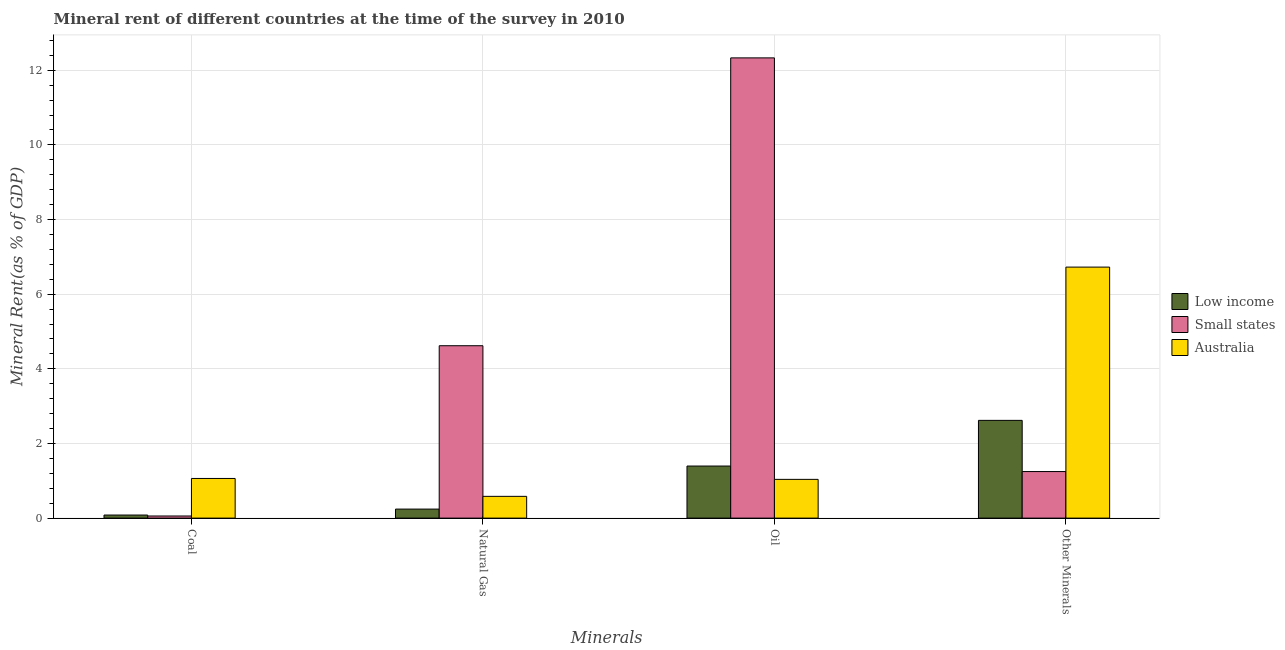Are the number of bars on each tick of the X-axis equal?
Keep it short and to the point. Yes. How many bars are there on the 1st tick from the right?
Provide a succinct answer. 3. What is the label of the 2nd group of bars from the left?
Ensure brevity in your answer.  Natural Gas. What is the natural gas rent in Small states?
Keep it short and to the point. 4.62. Across all countries, what is the maximum natural gas rent?
Your response must be concise. 4.62. Across all countries, what is the minimum  rent of other minerals?
Make the answer very short. 1.25. In which country was the  rent of other minerals minimum?
Make the answer very short. Small states. What is the total natural gas rent in the graph?
Provide a succinct answer. 5.44. What is the difference between the oil rent in Small states and that in Low income?
Your response must be concise. 10.94. What is the difference between the natural gas rent in Australia and the oil rent in Small states?
Your answer should be very brief. -11.75. What is the average coal rent per country?
Provide a short and direct response. 0.4. What is the difference between the coal rent and  rent of other minerals in Low income?
Your answer should be compact. -2.54. What is the ratio of the natural gas rent in Low income to that in Small states?
Provide a short and direct response. 0.05. Is the  rent of other minerals in Low income less than that in Small states?
Ensure brevity in your answer.  No. What is the difference between the highest and the second highest natural gas rent?
Ensure brevity in your answer.  4.04. What is the difference between the highest and the lowest  rent of other minerals?
Give a very brief answer. 5.48. What does the 1st bar from the right in Other Minerals represents?
Make the answer very short. Australia. What is the difference between two consecutive major ticks on the Y-axis?
Provide a short and direct response. 2. Are the values on the major ticks of Y-axis written in scientific E-notation?
Make the answer very short. No. Does the graph contain any zero values?
Offer a very short reply. No. Does the graph contain grids?
Offer a very short reply. Yes. How are the legend labels stacked?
Provide a short and direct response. Vertical. What is the title of the graph?
Give a very brief answer. Mineral rent of different countries at the time of the survey in 2010. Does "Denmark" appear as one of the legend labels in the graph?
Provide a short and direct response. No. What is the label or title of the X-axis?
Give a very brief answer. Minerals. What is the label or title of the Y-axis?
Provide a succinct answer. Mineral Rent(as % of GDP). What is the Mineral Rent(as % of GDP) in Low income in Coal?
Offer a very short reply. 0.08. What is the Mineral Rent(as % of GDP) of Small states in Coal?
Offer a very short reply. 0.06. What is the Mineral Rent(as % of GDP) of Australia in Coal?
Keep it short and to the point. 1.06. What is the Mineral Rent(as % of GDP) of Low income in Natural Gas?
Ensure brevity in your answer.  0.24. What is the Mineral Rent(as % of GDP) in Small states in Natural Gas?
Offer a terse response. 4.62. What is the Mineral Rent(as % of GDP) in Australia in Natural Gas?
Offer a very short reply. 0.58. What is the Mineral Rent(as % of GDP) in Low income in Oil?
Your answer should be very brief. 1.4. What is the Mineral Rent(as % of GDP) of Small states in Oil?
Your answer should be very brief. 12.33. What is the Mineral Rent(as % of GDP) in Australia in Oil?
Offer a very short reply. 1.04. What is the Mineral Rent(as % of GDP) of Low income in Other Minerals?
Give a very brief answer. 2.62. What is the Mineral Rent(as % of GDP) of Small states in Other Minerals?
Offer a terse response. 1.25. What is the Mineral Rent(as % of GDP) in Australia in Other Minerals?
Provide a succinct answer. 6.72. Across all Minerals, what is the maximum Mineral Rent(as % of GDP) in Low income?
Your response must be concise. 2.62. Across all Minerals, what is the maximum Mineral Rent(as % of GDP) of Small states?
Provide a succinct answer. 12.33. Across all Minerals, what is the maximum Mineral Rent(as % of GDP) of Australia?
Provide a succinct answer. 6.72. Across all Minerals, what is the minimum Mineral Rent(as % of GDP) in Low income?
Give a very brief answer. 0.08. Across all Minerals, what is the minimum Mineral Rent(as % of GDP) in Small states?
Keep it short and to the point. 0.06. Across all Minerals, what is the minimum Mineral Rent(as % of GDP) of Australia?
Offer a very short reply. 0.58. What is the total Mineral Rent(as % of GDP) of Low income in the graph?
Offer a terse response. 4.34. What is the total Mineral Rent(as % of GDP) in Small states in the graph?
Keep it short and to the point. 18.25. What is the total Mineral Rent(as % of GDP) of Australia in the graph?
Provide a succinct answer. 9.41. What is the difference between the Mineral Rent(as % of GDP) in Low income in Coal and that in Natural Gas?
Give a very brief answer. -0.16. What is the difference between the Mineral Rent(as % of GDP) in Small states in Coal and that in Natural Gas?
Ensure brevity in your answer.  -4.56. What is the difference between the Mineral Rent(as % of GDP) in Australia in Coal and that in Natural Gas?
Your answer should be compact. 0.48. What is the difference between the Mineral Rent(as % of GDP) in Low income in Coal and that in Oil?
Keep it short and to the point. -1.31. What is the difference between the Mineral Rent(as % of GDP) of Small states in Coal and that in Oil?
Ensure brevity in your answer.  -12.27. What is the difference between the Mineral Rent(as % of GDP) of Australia in Coal and that in Oil?
Make the answer very short. 0.02. What is the difference between the Mineral Rent(as % of GDP) of Low income in Coal and that in Other Minerals?
Ensure brevity in your answer.  -2.54. What is the difference between the Mineral Rent(as % of GDP) in Small states in Coal and that in Other Minerals?
Give a very brief answer. -1.19. What is the difference between the Mineral Rent(as % of GDP) of Australia in Coal and that in Other Minerals?
Make the answer very short. -5.66. What is the difference between the Mineral Rent(as % of GDP) of Low income in Natural Gas and that in Oil?
Your answer should be compact. -1.15. What is the difference between the Mineral Rent(as % of GDP) of Small states in Natural Gas and that in Oil?
Offer a very short reply. -7.71. What is the difference between the Mineral Rent(as % of GDP) in Australia in Natural Gas and that in Oil?
Ensure brevity in your answer.  -0.45. What is the difference between the Mineral Rent(as % of GDP) of Low income in Natural Gas and that in Other Minerals?
Make the answer very short. -2.38. What is the difference between the Mineral Rent(as % of GDP) in Small states in Natural Gas and that in Other Minerals?
Offer a terse response. 3.37. What is the difference between the Mineral Rent(as % of GDP) in Australia in Natural Gas and that in Other Minerals?
Give a very brief answer. -6.14. What is the difference between the Mineral Rent(as % of GDP) of Low income in Oil and that in Other Minerals?
Your response must be concise. -1.22. What is the difference between the Mineral Rent(as % of GDP) of Small states in Oil and that in Other Minerals?
Make the answer very short. 11.08. What is the difference between the Mineral Rent(as % of GDP) of Australia in Oil and that in Other Minerals?
Offer a very short reply. -5.69. What is the difference between the Mineral Rent(as % of GDP) of Low income in Coal and the Mineral Rent(as % of GDP) of Small states in Natural Gas?
Make the answer very short. -4.54. What is the difference between the Mineral Rent(as % of GDP) in Low income in Coal and the Mineral Rent(as % of GDP) in Australia in Natural Gas?
Provide a short and direct response. -0.5. What is the difference between the Mineral Rent(as % of GDP) in Small states in Coal and the Mineral Rent(as % of GDP) in Australia in Natural Gas?
Give a very brief answer. -0.53. What is the difference between the Mineral Rent(as % of GDP) of Low income in Coal and the Mineral Rent(as % of GDP) of Small states in Oil?
Your answer should be compact. -12.25. What is the difference between the Mineral Rent(as % of GDP) of Low income in Coal and the Mineral Rent(as % of GDP) of Australia in Oil?
Offer a very short reply. -0.96. What is the difference between the Mineral Rent(as % of GDP) of Small states in Coal and the Mineral Rent(as % of GDP) of Australia in Oil?
Offer a very short reply. -0.98. What is the difference between the Mineral Rent(as % of GDP) of Low income in Coal and the Mineral Rent(as % of GDP) of Small states in Other Minerals?
Keep it short and to the point. -1.17. What is the difference between the Mineral Rent(as % of GDP) in Low income in Coal and the Mineral Rent(as % of GDP) in Australia in Other Minerals?
Keep it short and to the point. -6.64. What is the difference between the Mineral Rent(as % of GDP) in Small states in Coal and the Mineral Rent(as % of GDP) in Australia in Other Minerals?
Your response must be concise. -6.67. What is the difference between the Mineral Rent(as % of GDP) in Low income in Natural Gas and the Mineral Rent(as % of GDP) in Small states in Oil?
Give a very brief answer. -12.09. What is the difference between the Mineral Rent(as % of GDP) in Low income in Natural Gas and the Mineral Rent(as % of GDP) in Australia in Oil?
Make the answer very short. -0.8. What is the difference between the Mineral Rent(as % of GDP) in Small states in Natural Gas and the Mineral Rent(as % of GDP) in Australia in Oil?
Keep it short and to the point. 3.58. What is the difference between the Mineral Rent(as % of GDP) in Low income in Natural Gas and the Mineral Rent(as % of GDP) in Small states in Other Minerals?
Make the answer very short. -1.01. What is the difference between the Mineral Rent(as % of GDP) of Low income in Natural Gas and the Mineral Rent(as % of GDP) of Australia in Other Minerals?
Your answer should be compact. -6.48. What is the difference between the Mineral Rent(as % of GDP) of Small states in Natural Gas and the Mineral Rent(as % of GDP) of Australia in Other Minerals?
Ensure brevity in your answer.  -2.11. What is the difference between the Mineral Rent(as % of GDP) in Low income in Oil and the Mineral Rent(as % of GDP) in Small states in Other Minerals?
Make the answer very short. 0.15. What is the difference between the Mineral Rent(as % of GDP) of Low income in Oil and the Mineral Rent(as % of GDP) of Australia in Other Minerals?
Keep it short and to the point. -5.33. What is the difference between the Mineral Rent(as % of GDP) in Small states in Oil and the Mineral Rent(as % of GDP) in Australia in Other Minerals?
Make the answer very short. 5.61. What is the average Mineral Rent(as % of GDP) of Low income per Minerals?
Keep it short and to the point. 1.08. What is the average Mineral Rent(as % of GDP) in Small states per Minerals?
Keep it short and to the point. 4.56. What is the average Mineral Rent(as % of GDP) of Australia per Minerals?
Keep it short and to the point. 2.35. What is the difference between the Mineral Rent(as % of GDP) in Low income and Mineral Rent(as % of GDP) in Small states in Coal?
Give a very brief answer. 0.03. What is the difference between the Mineral Rent(as % of GDP) in Low income and Mineral Rent(as % of GDP) in Australia in Coal?
Keep it short and to the point. -0.98. What is the difference between the Mineral Rent(as % of GDP) of Small states and Mineral Rent(as % of GDP) of Australia in Coal?
Ensure brevity in your answer.  -1.01. What is the difference between the Mineral Rent(as % of GDP) of Low income and Mineral Rent(as % of GDP) of Small states in Natural Gas?
Provide a succinct answer. -4.38. What is the difference between the Mineral Rent(as % of GDP) of Low income and Mineral Rent(as % of GDP) of Australia in Natural Gas?
Ensure brevity in your answer.  -0.34. What is the difference between the Mineral Rent(as % of GDP) of Small states and Mineral Rent(as % of GDP) of Australia in Natural Gas?
Provide a short and direct response. 4.04. What is the difference between the Mineral Rent(as % of GDP) in Low income and Mineral Rent(as % of GDP) in Small states in Oil?
Offer a terse response. -10.94. What is the difference between the Mineral Rent(as % of GDP) of Low income and Mineral Rent(as % of GDP) of Australia in Oil?
Your answer should be compact. 0.36. What is the difference between the Mineral Rent(as % of GDP) in Small states and Mineral Rent(as % of GDP) in Australia in Oil?
Your answer should be very brief. 11.29. What is the difference between the Mineral Rent(as % of GDP) of Low income and Mineral Rent(as % of GDP) of Small states in Other Minerals?
Your answer should be compact. 1.37. What is the difference between the Mineral Rent(as % of GDP) in Low income and Mineral Rent(as % of GDP) in Australia in Other Minerals?
Give a very brief answer. -4.11. What is the difference between the Mineral Rent(as % of GDP) in Small states and Mineral Rent(as % of GDP) in Australia in Other Minerals?
Offer a terse response. -5.48. What is the ratio of the Mineral Rent(as % of GDP) in Low income in Coal to that in Natural Gas?
Provide a short and direct response. 0.34. What is the ratio of the Mineral Rent(as % of GDP) in Small states in Coal to that in Natural Gas?
Provide a succinct answer. 0.01. What is the ratio of the Mineral Rent(as % of GDP) of Australia in Coal to that in Natural Gas?
Your answer should be compact. 1.82. What is the ratio of the Mineral Rent(as % of GDP) in Low income in Coal to that in Oil?
Give a very brief answer. 0.06. What is the ratio of the Mineral Rent(as % of GDP) in Small states in Coal to that in Oil?
Provide a succinct answer. 0. What is the ratio of the Mineral Rent(as % of GDP) in Australia in Coal to that in Oil?
Provide a succinct answer. 1.02. What is the ratio of the Mineral Rent(as % of GDP) in Low income in Coal to that in Other Minerals?
Offer a very short reply. 0.03. What is the ratio of the Mineral Rent(as % of GDP) of Small states in Coal to that in Other Minerals?
Provide a succinct answer. 0.05. What is the ratio of the Mineral Rent(as % of GDP) of Australia in Coal to that in Other Minerals?
Your answer should be compact. 0.16. What is the ratio of the Mineral Rent(as % of GDP) of Low income in Natural Gas to that in Oil?
Your answer should be very brief. 0.17. What is the ratio of the Mineral Rent(as % of GDP) of Small states in Natural Gas to that in Oil?
Your answer should be very brief. 0.37. What is the ratio of the Mineral Rent(as % of GDP) of Australia in Natural Gas to that in Oil?
Offer a terse response. 0.56. What is the ratio of the Mineral Rent(as % of GDP) in Low income in Natural Gas to that in Other Minerals?
Your response must be concise. 0.09. What is the ratio of the Mineral Rent(as % of GDP) of Small states in Natural Gas to that in Other Minerals?
Offer a very short reply. 3.7. What is the ratio of the Mineral Rent(as % of GDP) of Australia in Natural Gas to that in Other Minerals?
Your answer should be very brief. 0.09. What is the ratio of the Mineral Rent(as % of GDP) in Low income in Oil to that in Other Minerals?
Keep it short and to the point. 0.53. What is the ratio of the Mineral Rent(as % of GDP) of Small states in Oil to that in Other Minerals?
Keep it short and to the point. 9.89. What is the ratio of the Mineral Rent(as % of GDP) of Australia in Oil to that in Other Minerals?
Provide a succinct answer. 0.15. What is the difference between the highest and the second highest Mineral Rent(as % of GDP) of Low income?
Ensure brevity in your answer.  1.22. What is the difference between the highest and the second highest Mineral Rent(as % of GDP) of Small states?
Your answer should be compact. 7.71. What is the difference between the highest and the second highest Mineral Rent(as % of GDP) in Australia?
Your answer should be very brief. 5.66. What is the difference between the highest and the lowest Mineral Rent(as % of GDP) in Low income?
Make the answer very short. 2.54. What is the difference between the highest and the lowest Mineral Rent(as % of GDP) of Small states?
Provide a short and direct response. 12.27. What is the difference between the highest and the lowest Mineral Rent(as % of GDP) of Australia?
Your answer should be very brief. 6.14. 